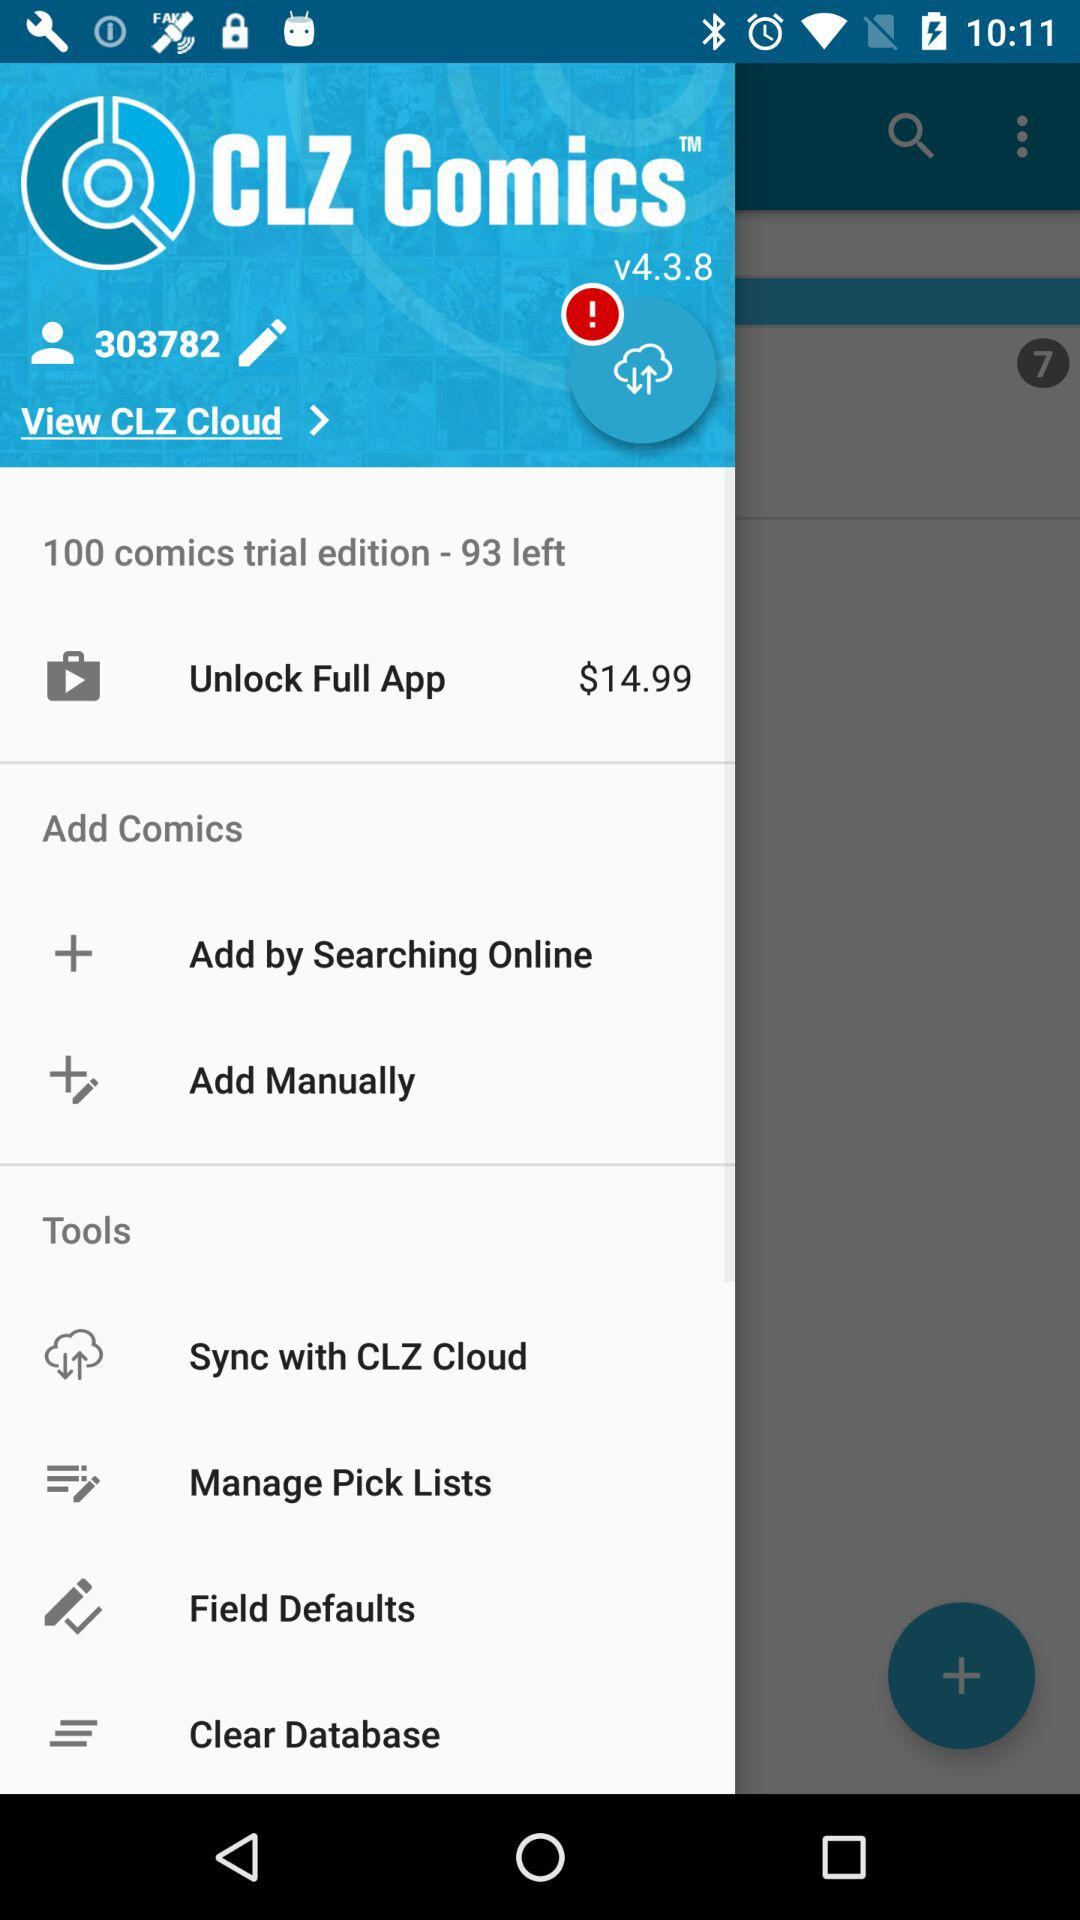Which version is this? This version is v4.3.8. 